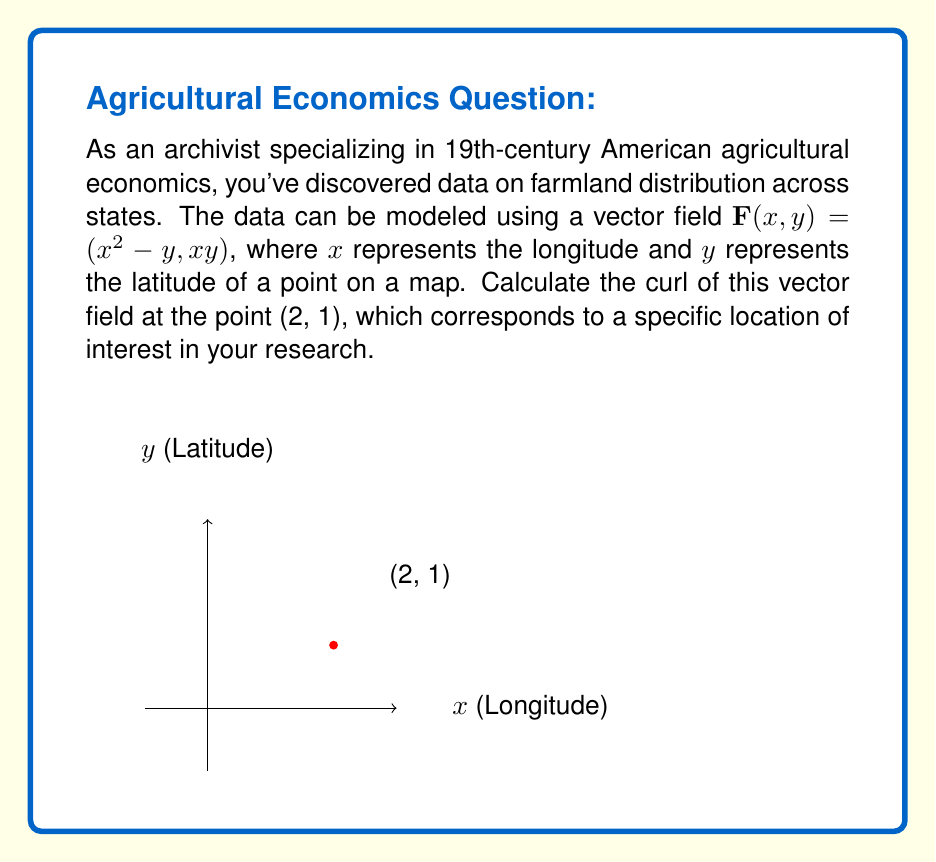What is the answer to this math problem? To solve this problem, we'll follow these steps:

1) The curl of a vector field $\mathbf{F}(x,y) = (P(x,y), Q(x,y))$ in two dimensions is given by:

   $$\text{curl } \mathbf{F} = \frac{\partial Q}{\partial x} - \frac{\partial P}{\partial y}$$

2) In our case, $P(x,y) = x^2 - y$ and $Q(x,y) = xy$

3) Let's calculate the partial derivatives:

   $$\frac{\partial Q}{\partial x} = \frac{\partial}{\partial x}(xy) = y$$

   $$\frac{\partial P}{\partial y} = \frac{\partial}{\partial y}(x^2 - y) = -1$$

4) Now we can substitute these into the curl formula:

   $$\text{curl } \mathbf{F} = \frac{\partial Q}{\partial x} - \frac{\partial P}{\partial y} = y - (-1) = y + 1$$

5) We want to evaluate this at the point (2, 1), so we substitute y = 1:

   $$\text{curl } \mathbf{F}(2,1) = 1 + 1 = 2$$

This result indicates the amount of rotation in the farmland distribution model at the specific location (2, 1) on your map.
Answer: $2$ 